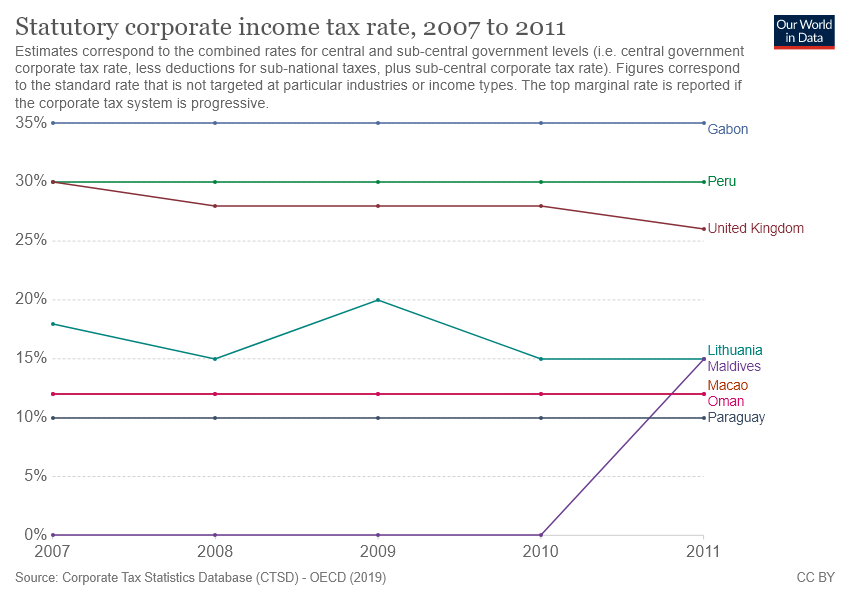Indicate a few pertinent items in this graphic. The country of Gabon represents the first line on the chart. The statutory corporate income tax rate in Lithuania between 2009 and 2010 was 0.05. 